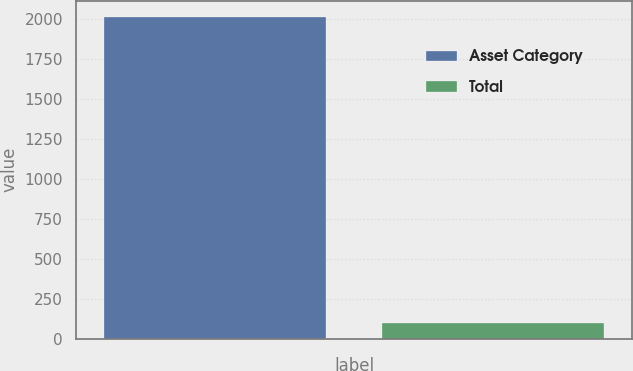<chart> <loc_0><loc_0><loc_500><loc_500><bar_chart><fcel>Asset Category<fcel>Total<nl><fcel>2013<fcel>100<nl></chart> 